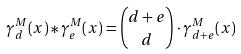Convert formula to latex. <formula><loc_0><loc_0><loc_500><loc_500>\gamma _ { d } ^ { M } ( x ) * \gamma _ { e } ^ { M } ( x ) = \binom { d + e } { d } \cdot \gamma _ { d + e } ^ { M } ( x )</formula> 